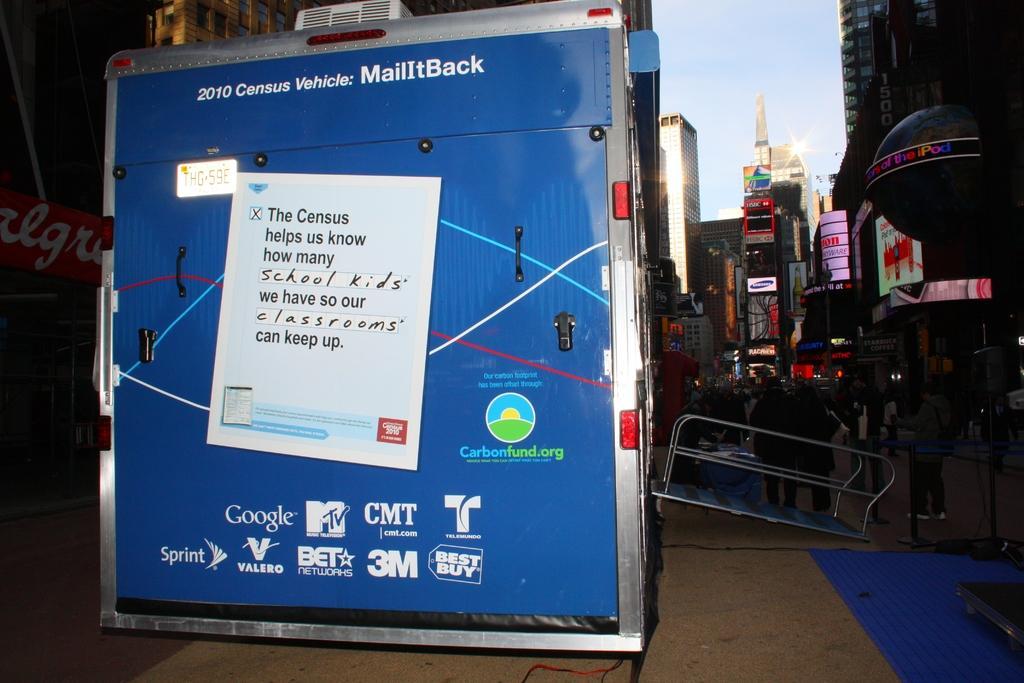In one or two sentences, can you explain what this image depicts? This looks like a van. I can see a poster, which is attached to the van. There are group of people standing. These are the buildings with the name boards. I think this is board with holders. 